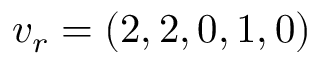<formula> <loc_0><loc_0><loc_500><loc_500>v _ { r } = ( 2 , 2 , 0 , 1 , 0 )</formula> 